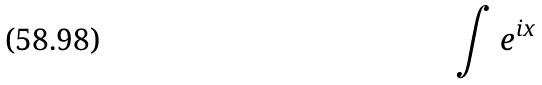Convert formula to latex. <formula><loc_0><loc_0><loc_500><loc_500>\int e ^ { i x }</formula> 